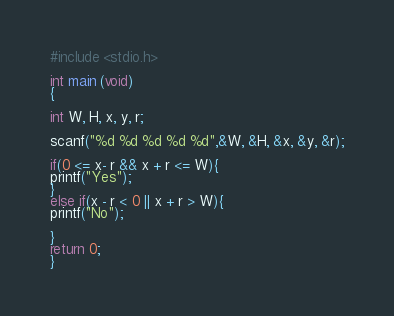<code> <loc_0><loc_0><loc_500><loc_500><_C_>#include <stdio.h>

int main (void)
{

int W, H, x, y, r;

scanf("%d %d %d %d %d",&W, &H, &x, &y, &r);

if(0 <= x- r && x + r <= W){
printf("Yes");
}
else if(x - r < 0 || x + r > W){
printf("No");

}
return 0;
}</code> 